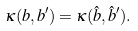Convert formula to latex. <formula><loc_0><loc_0><loc_500><loc_500>\kappa ( b , b ^ { \prime } ) = \kappa ( \hat { b } , \hat { b } ^ { \prime } ) .</formula> 